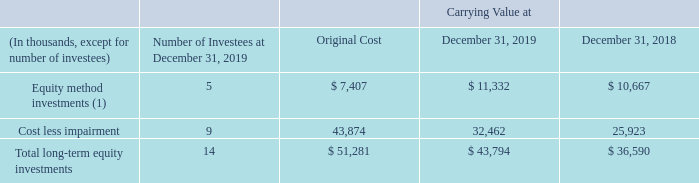Other Acquisitions, Divestitures and Investments
On June 15, 2018, we acquired all the outstanding minority interests in a third party for $6.9 million. We initially acquired a controlling interest in the third party in April 2015. Therefore, this transaction was treated as an equity transaction, and the cash payment is reported as part of cash flow from financing activities in the consolidated statement of cash flows for the year ended December 31, 2018.
On April 2, 2018, we sold substantially all of the assets of the Allscripts’ business providing hospitals and health systems document and other content management software and services generally known as “OneContent” to Hyland Software, Inc., an Ohio corporation (“Hyland”). Allscripts acquired the OneContent business during the fourth quarter of 2017 through the acquisition of the EIS Business (as defined below). Certain assets of Allscripts relating to the OneContent business were excluded from the transaction and retained by Allscripts.
In addition, Hyland assumed certain liabilities related to the OneContent business. The total consideration for the OneContent business was $260 million, which was subject to certain adjustments for liabilities assumed by Hyland and net working capital. We realized a pre-tax gain upon sale of $177.9 million which is included in the “Gain on sales of businesses, net” line in our consolidated statements of operations for the year ended December 31, 2018.
On March 15, 2018, we contributed certain assets and liabilities of our Strategic Sourcing business unit, acquired as part of the acquisition of the EIS Business in 2017, into a new entity together with $2.7 million of cash as additional consideration. In exchange for our contributions, we obtained a 35.7% interest in the new entity, which was valued at $4.0 million, and is included in Other assets in our consolidated balance sheet as of December 31, 2018.
This investment is accounted for under the equity method of accounting. As a result of this transaction, we recognized an initial pre-tax loss of $0.9 million and $4.7 million in additional losses due to measurement period adjustments upon the finalization of carve-out balances, mainly related to accounts receivable. These losses are included on the “Gain on sale of businesses, net” line in our consolidated statements of operations for the year ended December 31, 2018.
On February 6, 2018, we acquired all of the common stock of a cloud-based analytics software platform provider for a purchase price of $8.0 million in cash. The allocation of the consideration is as follows: $1.1 million of intangible assets related to technology; $0.6 million to customer relationships; $6.6 million of goodwill; $0.8 million to accounts receivable; deferred revenue of $0.6 million and $0.5 million of long-term deferred income tax liabilities.
The allocation was finalized in the fourth quarter of 2018. The acquired intangible asset related to technology will be amortized over 8 years using a method that approximates the pattern of economic benefits to be gained from the intangible asset. The customer relationship was amortized over one year. The goodwill is not deductible for tax purposes. The results of operations of this acquisition were not material to our consolidated financial statements.
The following table summarizes our other equity investments which are included in other assets in the accompanying consolidated balance sheets: (1) Allscripts share of the earnings of our equity method investees is reported based on a one quarter lag.
During 2018, we acquired certain non-marketable equity securities of two third parties and entered into a commercial agreement with one of the third parties for total consideration of $11.7 million. During 2018, we also acquired a $1.8 million non-marketable convertible note of a third party. These investments are recorded in the Other asset caption within the consolidated balance sheets.
It is not practicable to estimate the fair value of our equity investments primarily because of their illiquidity and restricted marketability as of December 31, 2019. The factors we considered in trying to determine fair value include, but are not limited to, available financial information, the issuer’s ability to meet its current obligations and the issuer’s subsequent or planned raises of capital.
For what amount was the outstanding minority interests in a third party acquired? $6.9 million. On which date was the assets of the Allscripts’ business sold? April 2, 2018. What was the total consideration for OneContent business? $260 million. What is the change in the Equity method investments from 2018 to 2019?
Answer scale should be: thousand. 11,332 - 10,667
Answer: 665. What is the average Cost less impairment for 2018 and 2019?
Answer scale should be: thousand. (32,462 + 25,923) / 2
Answer: 29192.5. What is the change in the Total long-term equity investments from 2018 to 2019?
Answer scale should be: thousand. 43,794 - 36,590
Answer: 7204. 